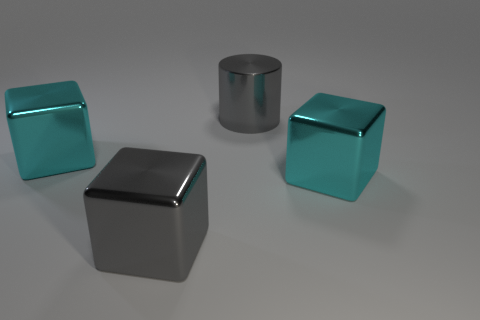Subtract all green cylinders. How many cyan cubes are left? 2 Subtract all large cyan cubes. How many cubes are left? 1 Subtract all cubes. How many objects are left? 1 Add 1 small red rubber balls. How many objects exist? 5 Subtract all large cyan metal blocks. Subtract all cyan cubes. How many objects are left? 0 Add 1 gray shiny cubes. How many gray shiny cubes are left? 2 Add 1 large gray metallic blocks. How many large gray metallic blocks exist? 2 Subtract 0 yellow balls. How many objects are left? 4 